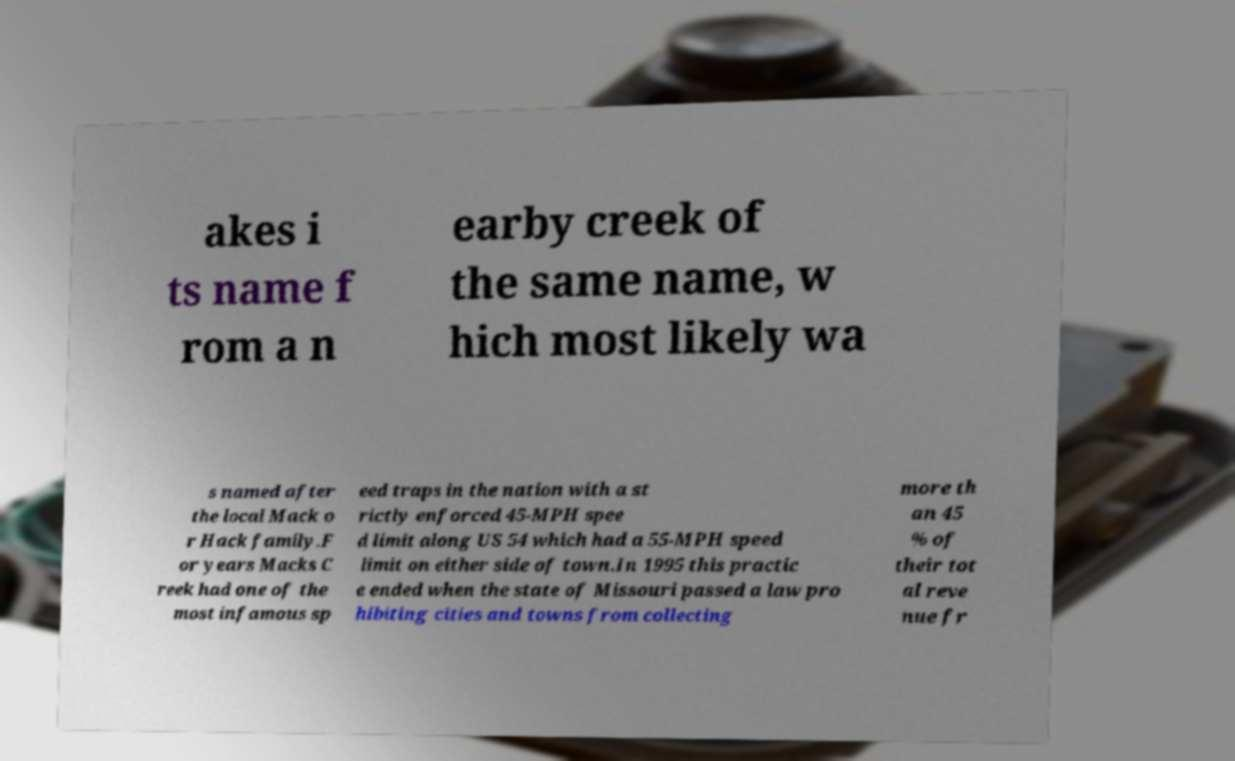Could you extract and type out the text from this image? akes i ts name f rom a n earby creek of the same name, w hich most likely wa s named after the local Mack o r Hack family.F or years Macks C reek had one of the most infamous sp eed traps in the nation with a st rictly enforced 45-MPH spee d limit along US 54 which had a 55-MPH speed limit on either side of town.In 1995 this practic e ended when the state of Missouri passed a law pro hibiting cities and towns from collecting more th an 45 % of their tot al reve nue fr 